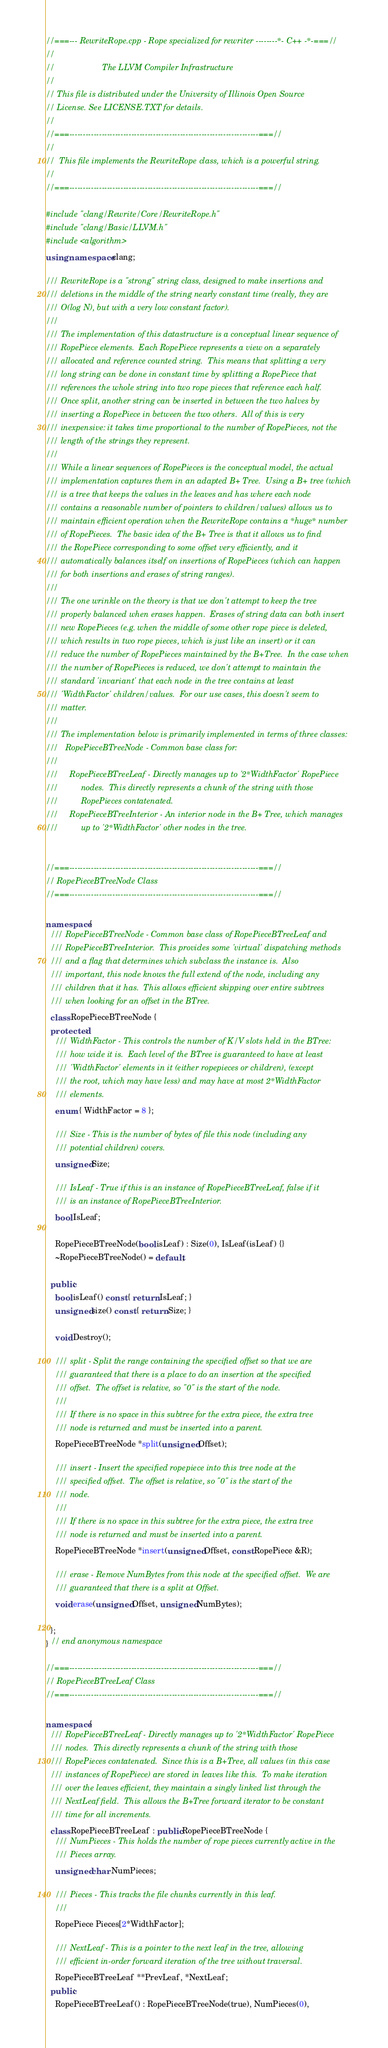Convert code to text. <code><loc_0><loc_0><loc_500><loc_500><_C++_>//===--- RewriteRope.cpp - Rope specialized for rewriter --------*- C++ -*-===//
//
//                     The LLVM Compiler Infrastructure
//
// This file is distributed under the University of Illinois Open Source
// License. See LICENSE.TXT for details.
//
//===----------------------------------------------------------------------===//
//
//  This file implements the RewriteRope class, which is a powerful string.
//
//===----------------------------------------------------------------------===//

#include "clang/Rewrite/Core/RewriteRope.h"
#include "clang/Basic/LLVM.h"
#include <algorithm>
using namespace clang;

/// RewriteRope is a "strong" string class, designed to make insertions and
/// deletions in the middle of the string nearly constant time (really, they are
/// O(log N), but with a very low constant factor).
///
/// The implementation of this datastructure is a conceptual linear sequence of
/// RopePiece elements.  Each RopePiece represents a view on a separately
/// allocated and reference counted string.  This means that splitting a very
/// long string can be done in constant time by splitting a RopePiece that
/// references the whole string into two rope pieces that reference each half.
/// Once split, another string can be inserted in between the two halves by
/// inserting a RopePiece in between the two others.  All of this is very
/// inexpensive: it takes time proportional to the number of RopePieces, not the
/// length of the strings they represent.
///
/// While a linear sequences of RopePieces is the conceptual model, the actual
/// implementation captures them in an adapted B+ Tree.  Using a B+ tree (which
/// is a tree that keeps the values in the leaves and has where each node
/// contains a reasonable number of pointers to children/values) allows us to
/// maintain efficient operation when the RewriteRope contains a *huge* number
/// of RopePieces.  The basic idea of the B+ Tree is that it allows us to find
/// the RopePiece corresponding to some offset very efficiently, and it
/// automatically balances itself on insertions of RopePieces (which can happen
/// for both insertions and erases of string ranges).
///
/// The one wrinkle on the theory is that we don't attempt to keep the tree
/// properly balanced when erases happen.  Erases of string data can both insert
/// new RopePieces (e.g. when the middle of some other rope piece is deleted,
/// which results in two rope pieces, which is just like an insert) or it can
/// reduce the number of RopePieces maintained by the B+Tree.  In the case when
/// the number of RopePieces is reduced, we don't attempt to maintain the
/// standard 'invariant' that each node in the tree contains at least
/// 'WidthFactor' children/values.  For our use cases, this doesn't seem to
/// matter.
///
/// The implementation below is primarily implemented in terms of three classes:
///   RopePieceBTreeNode - Common base class for:
///
///     RopePieceBTreeLeaf - Directly manages up to '2*WidthFactor' RopePiece
///          nodes.  This directly represents a chunk of the string with those
///          RopePieces contatenated.
///     RopePieceBTreeInterior - An interior node in the B+ Tree, which manages
///          up to '2*WidthFactor' other nodes in the tree.


//===----------------------------------------------------------------------===//
// RopePieceBTreeNode Class
//===----------------------------------------------------------------------===//

namespace {
  /// RopePieceBTreeNode - Common base class of RopePieceBTreeLeaf and
  /// RopePieceBTreeInterior.  This provides some 'virtual' dispatching methods
  /// and a flag that determines which subclass the instance is.  Also
  /// important, this node knows the full extend of the node, including any
  /// children that it has.  This allows efficient skipping over entire subtrees
  /// when looking for an offset in the BTree.
  class RopePieceBTreeNode {
  protected:
    /// WidthFactor - This controls the number of K/V slots held in the BTree:
    /// how wide it is.  Each level of the BTree is guaranteed to have at least
    /// 'WidthFactor' elements in it (either ropepieces or children), (except
    /// the root, which may have less) and may have at most 2*WidthFactor
    /// elements.
    enum { WidthFactor = 8 };

    /// Size - This is the number of bytes of file this node (including any
    /// potential children) covers.
    unsigned Size;

    /// IsLeaf - True if this is an instance of RopePieceBTreeLeaf, false if it
    /// is an instance of RopePieceBTreeInterior.
    bool IsLeaf;

    RopePieceBTreeNode(bool isLeaf) : Size(0), IsLeaf(isLeaf) {}
    ~RopePieceBTreeNode() = default;

  public:
    bool isLeaf() const { return IsLeaf; }
    unsigned size() const { return Size; }

    void Destroy();

    /// split - Split the range containing the specified offset so that we are
    /// guaranteed that there is a place to do an insertion at the specified
    /// offset.  The offset is relative, so "0" is the start of the node.
    ///
    /// If there is no space in this subtree for the extra piece, the extra tree
    /// node is returned and must be inserted into a parent.
    RopePieceBTreeNode *split(unsigned Offset);

    /// insert - Insert the specified ropepiece into this tree node at the
    /// specified offset.  The offset is relative, so "0" is the start of the
    /// node.
    ///
    /// If there is no space in this subtree for the extra piece, the extra tree
    /// node is returned and must be inserted into a parent.
    RopePieceBTreeNode *insert(unsigned Offset, const RopePiece &R);

    /// erase - Remove NumBytes from this node at the specified offset.  We are
    /// guaranteed that there is a split at Offset.
    void erase(unsigned Offset, unsigned NumBytes);

  };
} // end anonymous namespace

//===----------------------------------------------------------------------===//
// RopePieceBTreeLeaf Class
//===----------------------------------------------------------------------===//

namespace {
  /// RopePieceBTreeLeaf - Directly manages up to '2*WidthFactor' RopePiece
  /// nodes.  This directly represents a chunk of the string with those
  /// RopePieces contatenated.  Since this is a B+Tree, all values (in this case
  /// instances of RopePiece) are stored in leaves like this.  To make iteration
  /// over the leaves efficient, they maintain a singly linked list through the
  /// NextLeaf field.  This allows the B+Tree forward iterator to be constant
  /// time for all increments.
  class RopePieceBTreeLeaf : public RopePieceBTreeNode {
    /// NumPieces - This holds the number of rope pieces currently active in the
    /// Pieces array.
    unsigned char NumPieces;

    /// Pieces - This tracks the file chunks currently in this leaf.
    ///
    RopePiece Pieces[2*WidthFactor];

    /// NextLeaf - This is a pointer to the next leaf in the tree, allowing
    /// efficient in-order forward iteration of the tree without traversal.
    RopePieceBTreeLeaf **PrevLeaf, *NextLeaf;
  public:
    RopePieceBTreeLeaf() : RopePieceBTreeNode(true), NumPieces(0),</code> 